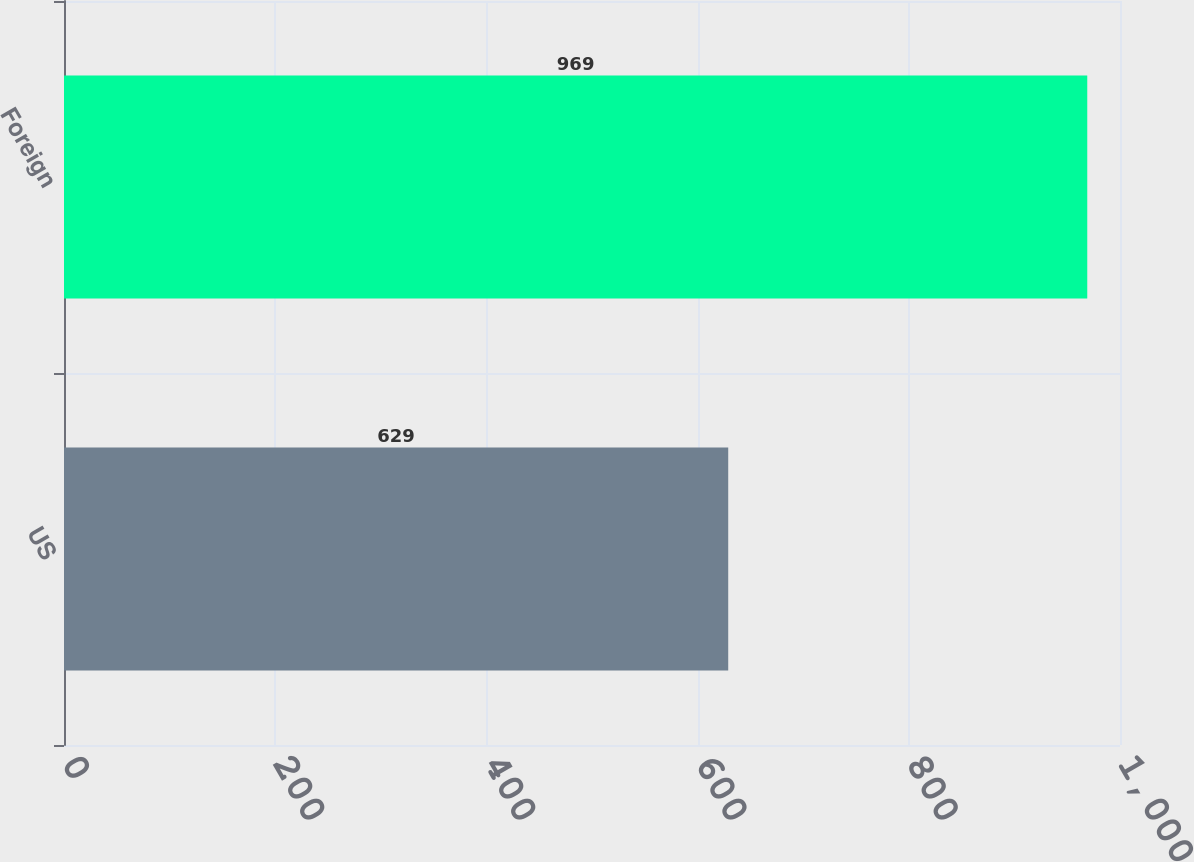Convert chart to OTSL. <chart><loc_0><loc_0><loc_500><loc_500><bar_chart><fcel>US<fcel>Foreign<nl><fcel>629<fcel>969<nl></chart> 